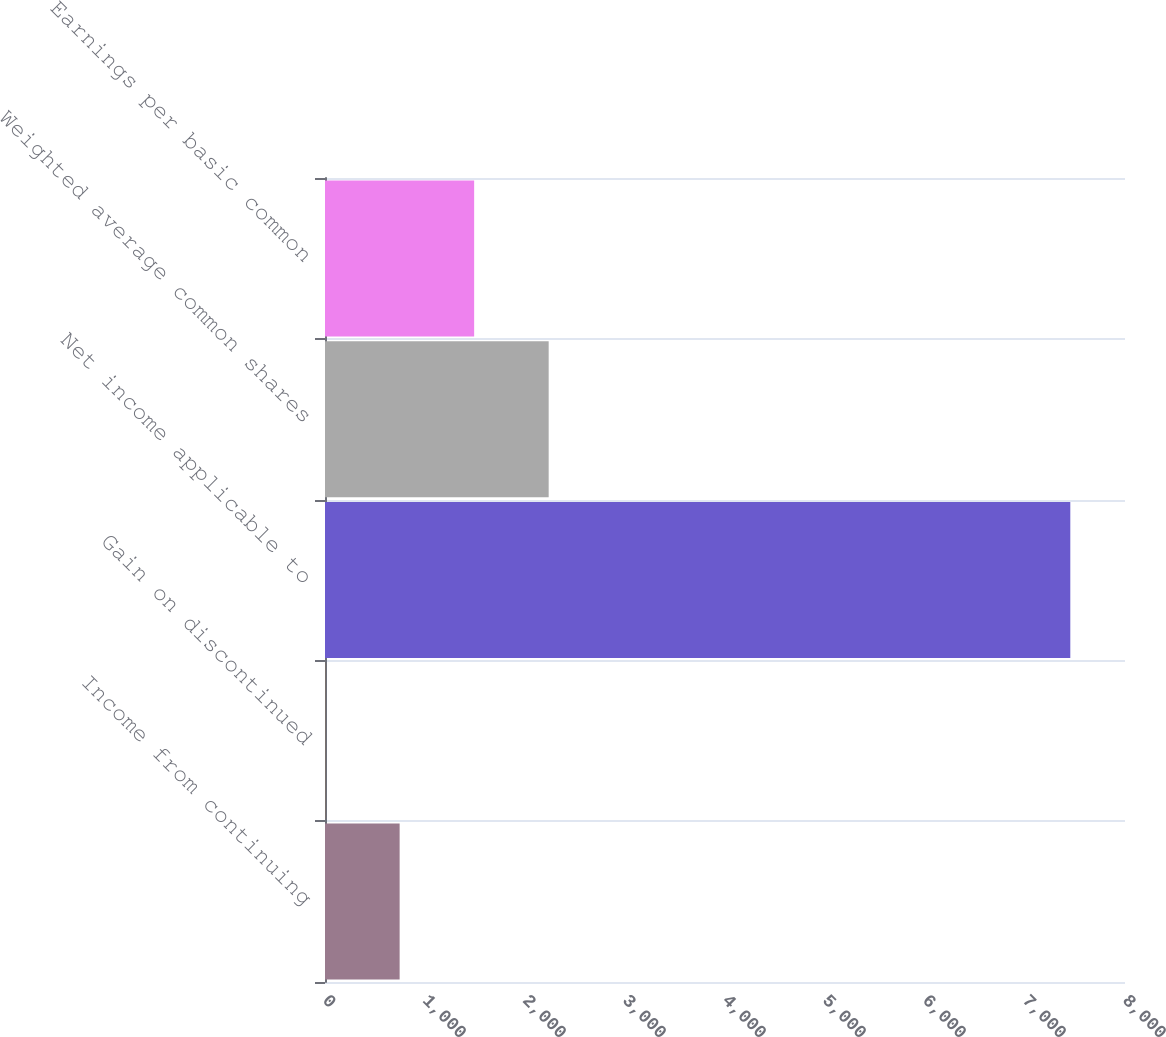Convert chart to OTSL. <chart><loc_0><loc_0><loc_500><loc_500><bar_chart><fcel>Income from continuing<fcel>Gain on discontinued<fcel>Net income applicable to<fcel>Weighted average common shares<fcel>Earnings per basic common<nl><fcel>746.32<fcel>1.13<fcel>7453<fcel>2236.7<fcel>1491.51<nl></chart> 